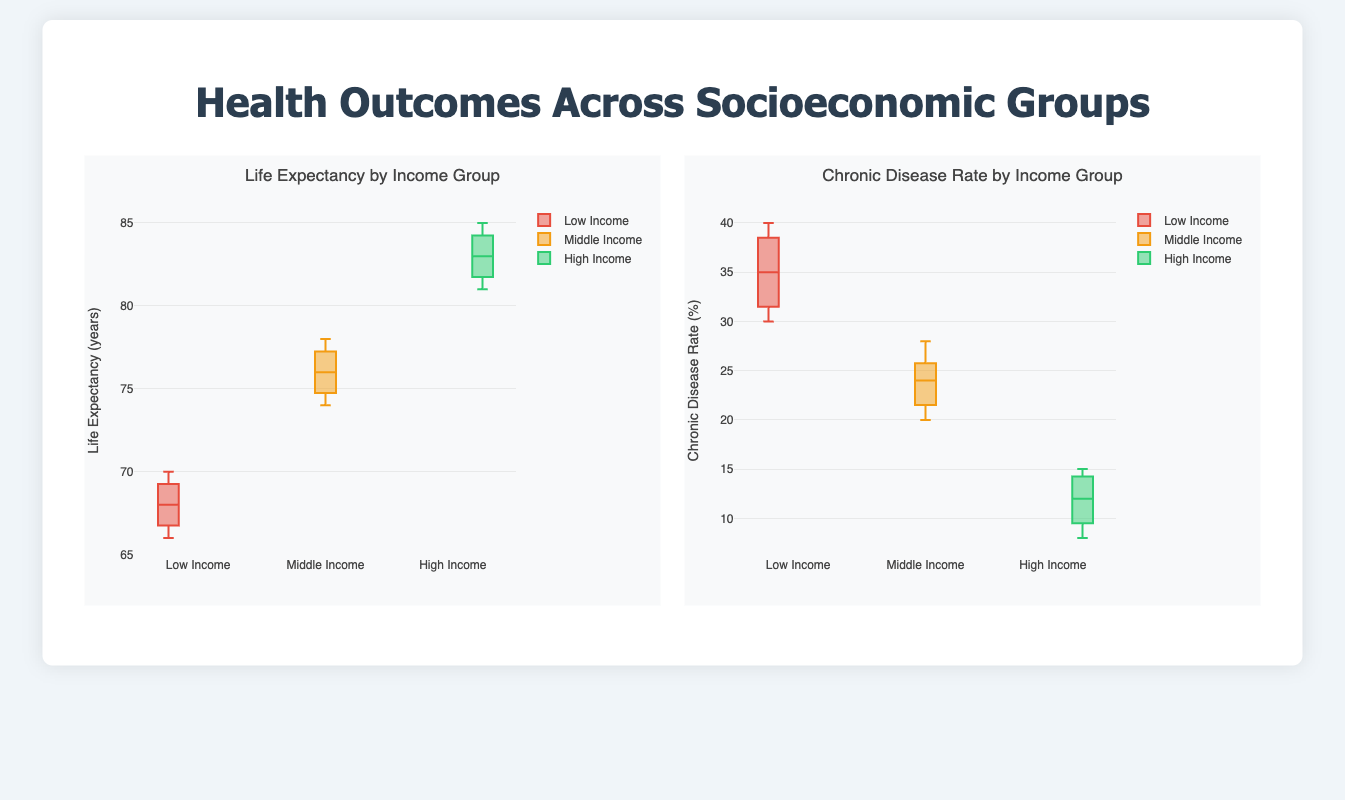What is the title of the chart displaying life expectancy? The title of the life expectancy chart is located at the top of the chart. It reads "Life Expectancy by Income Group".
Answer: Life Expectancy by Income Group Which income group has the highest median life expectancy? By looking at the box plots of life expectancy, we can see that the highest median life expectancy corresponds to the plot for the "High Income" group.
Answer: High Income What is the range of chronic disease rates for the Low Income group? The range of chronic disease rates for the Low Income group is the difference between the maximum and minimum points in the box plot. The maximum is 40%, and the minimum is 30%, so the range is 40 - 30 = 10%.
Answer: 10% What is the interquartile range (IQR) of life expectancy for the Middle Income group? The IQR is the range between the first (Q1) and third quartiles (Q3). For the Middle Income group, Q1 is 74 years and Q3 is 77 years, so the IQR is 77 - 74 = 3 years.
Answer: 3 years How does the chronic disease rate of the High Income group compare to the Low Income group? By comparing the two box plots for chronic disease rates, the High Income group has significantly lower chronic disease rates than the Low Income group. The midpoints and the ranges indicate that rates are lower in the High Income group.
Answer: Lower in High Income Are there any outliers in the life expectancy data for the Low Income group? Outliers in box plots are typically represented by points that fall outside the whiskers. In the Low Income group's life expectancy data, there do not appear to be any such outliers.
Answer: None Which income group has the narrowest range of chronic disease rates? The narrowest range is identified by looking at the length of the whiskers in the box plots for chronic disease rates. The "High Income" group has the shortest whiskers, indicating the narrowest range.
Answer: High Income What is the median chronic disease rate for the Middle Income group? The median is represented by the line inside each box of the box plot. For the Middle Income group, the median chronic disease rate is around 24%.
Answer: 24% Identify which income group generally has the highest life expectancy and the lowest chronic disease rate. By examining the median lines and general distribution, the High Income group has the highest median life expectancy and the lowest median chronic disease rate.
Answer: High Income Compare the variation in life expectancy between Low Income and High Income groups. Variation can be assessed by the length of the box and whiskers. The Low Income group's box plot shows a wider spread compared to the High Income group, indicating greater variation in life expectancy for Low Income.
Answer: Greater variation in Low Income 